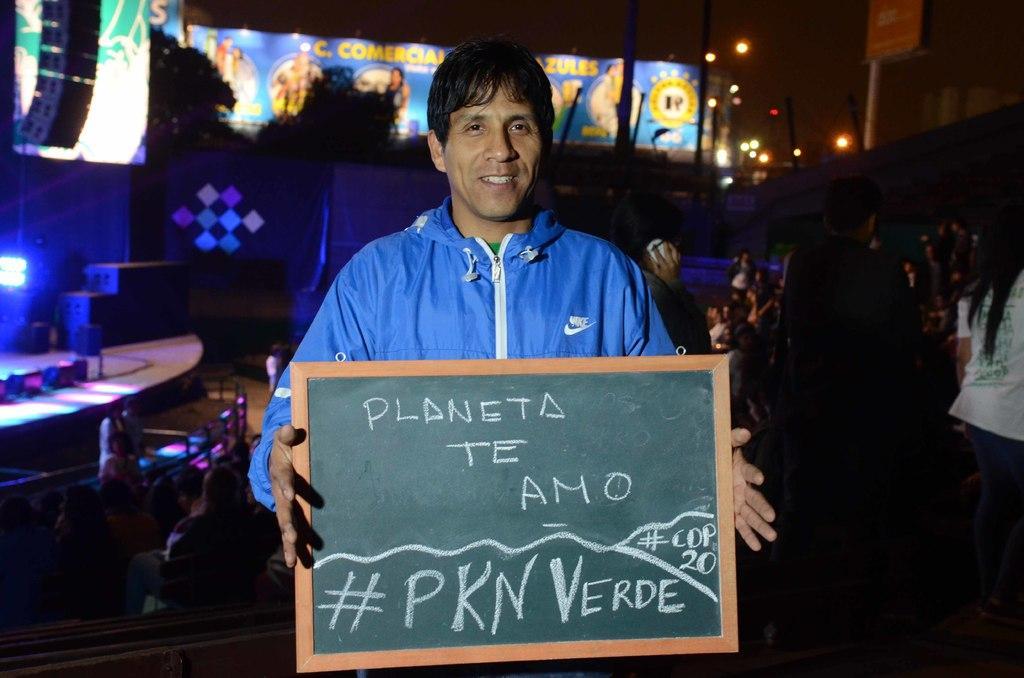Could you give a brief overview of what you see in this image? In this picture I can observe a man in the middle of the picture, holding a small black board in his hands. Man is smiling. In the background I can observe some people. 